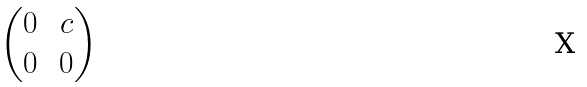Convert formula to latex. <formula><loc_0><loc_0><loc_500><loc_500>\begin{pmatrix} 0 & \, c \\ 0 & \, 0 \end{pmatrix}</formula> 